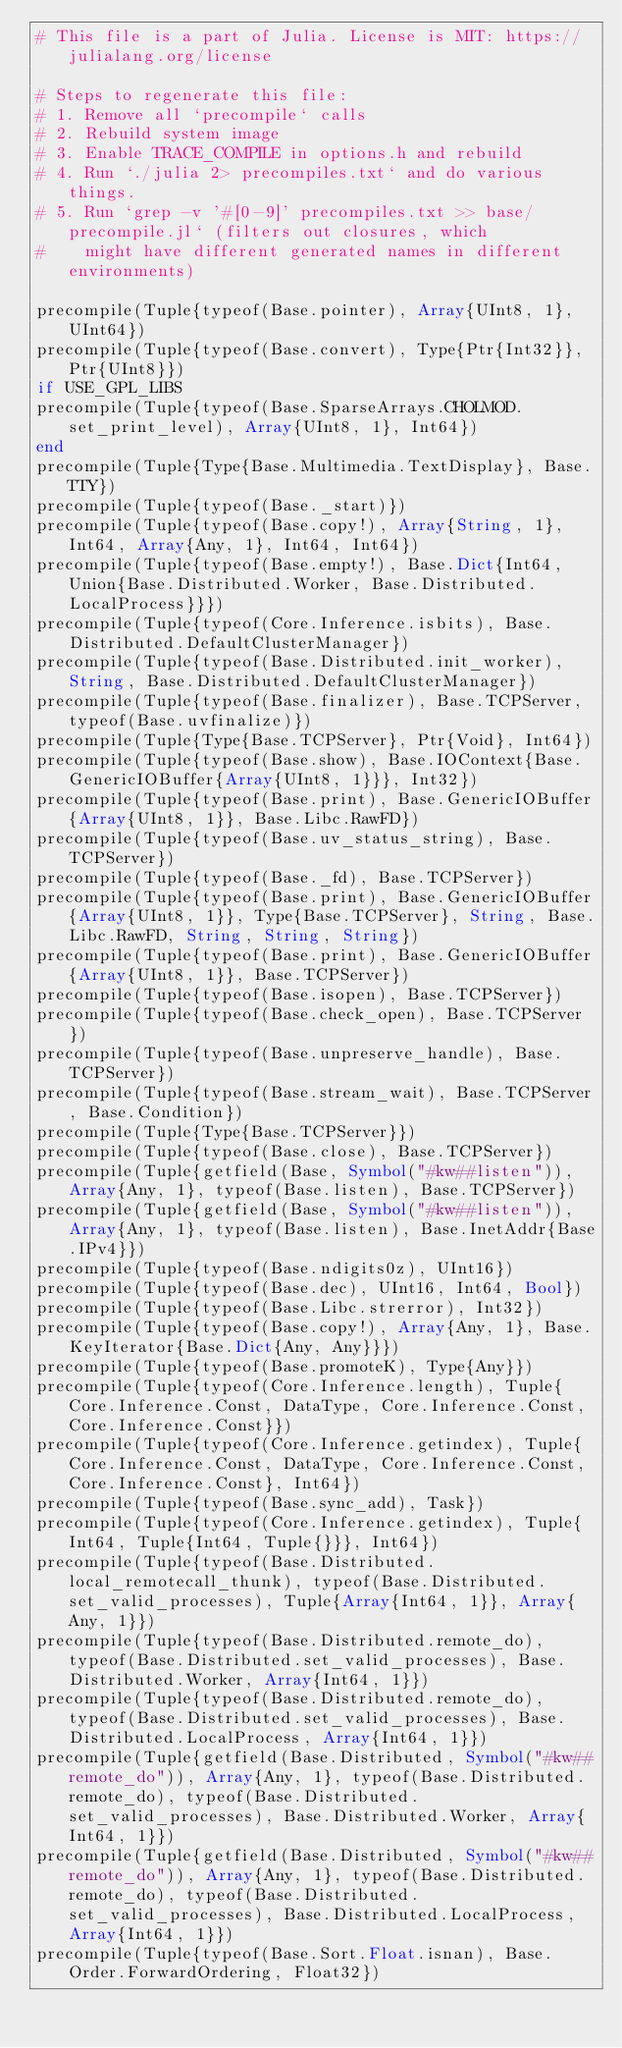<code> <loc_0><loc_0><loc_500><loc_500><_Julia_># This file is a part of Julia. License is MIT: https://julialang.org/license

# Steps to regenerate this file:
# 1. Remove all `precompile` calls
# 2. Rebuild system image
# 3. Enable TRACE_COMPILE in options.h and rebuild
# 4. Run `./julia 2> precompiles.txt` and do various things.
# 5. Run `grep -v '#[0-9]' precompiles.txt >> base/precompile.jl` (filters out closures, which
#    might have different generated names in different environments)

precompile(Tuple{typeof(Base.pointer), Array{UInt8, 1}, UInt64})
precompile(Tuple{typeof(Base.convert), Type{Ptr{Int32}}, Ptr{UInt8}})
if USE_GPL_LIBS
precompile(Tuple{typeof(Base.SparseArrays.CHOLMOD.set_print_level), Array{UInt8, 1}, Int64})
end
precompile(Tuple{Type{Base.Multimedia.TextDisplay}, Base.TTY})
precompile(Tuple{typeof(Base._start)})
precompile(Tuple{typeof(Base.copy!), Array{String, 1}, Int64, Array{Any, 1}, Int64, Int64})
precompile(Tuple{typeof(Base.empty!), Base.Dict{Int64, Union{Base.Distributed.Worker, Base.Distributed.LocalProcess}}})
precompile(Tuple{typeof(Core.Inference.isbits), Base.Distributed.DefaultClusterManager})
precompile(Tuple{typeof(Base.Distributed.init_worker), String, Base.Distributed.DefaultClusterManager})
precompile(Tuple{typeof(Base.finalizer), Base.TCPServer, typeof(Base.uvfinalize)})
precompile(Tuple{Type{Base.TCPServer}, Ptr{Void}, Int64})
precompile(Tuple{typeof(Base.show), Base.IOContext{Base.GenericIOBuffer{Array{UInt8, 1}}}, Int32})
precompile(Tuple{typeof(Base.print), Base.GenericIOBuffer{Array{UInt8, 1}}, Base.Libc.RawFD})
precompile(Tuple{typeof(Base.uv_status_string), Base.TCPServer})
precompile(Tuple{typeof(Base._fd), Base.TCPServer})
precompile(Tuple{typeof(Base.print), Base.GenericIOBuffer{Array{UInt8, 1}}, Type{Base.TCPServer}, String, Base.Libc.RawFD, String, String, String})
precompile(Tuple{typeof(Base.print), Base.GenericIOBuffer{Array{UInt8, 1}}, Base.TCPServer})
precompile(Tuple{typeof(Base.isopen), Base.TCPServer})
precompile(Tuple{typeof(Base.check_open), Base.TCPServer})
precompile(Tuple{typeof(Base.unpreserve_handle), Base.TCPServer})
precompile(Tuple{typeof(Base.stream_wait), Base.TCPServer, Base.Condition})
precompile(Tuple{Type{Base.TCPServer}})
precompile(Tuple{typeof(Base.close), Base.TCPServer})
precompile(Tuple{getfield(Base, Symbol("#kw##listen")), Array{Any, 1}, typeof(Base.listen), Base.TCPServer})
precompile(Tuple{getfield(Base, Symbol("#kw##listen")), Array{Any, 1}, typeof(Base.listen), Base.InetAddr{Base.IPv4}})
precompile(Tuple{typeof(Base.ndigits0z), UInt16})
precompile(Tuple{typeof(Base.dec), UInt16, Int64, Bool})
precompile(Tuple{typeof(Base.Libc.strerror), Int32})
precompile(Tuple{typeof(Base.copy!), Array{Any, 1}, Base.KeyIterator{Base.Dict{Any, Any}}})
precompile(Tuple{typeof(Base.promoteK), Type{Any}})
precompile(Tuple{typeof(Core.Inference.length), Tuple{Core.Inference.Const, DataType, Core.Inference.Const, Core.Inference.Const}})
precompile(Tuple{typeof(Core.Inference.getindex), Tuple{Core.Inference.Const, DataType, Core.Inference.Const, Core.Inference.Const}, Int64})
precompile(Tuple{typeof(Base.sync_add), Task})
precompile(Tuple{typeof(Core.Inference.getindex), Tuple{Int64, Tuple{Int64, Tuple{}}}, Int64})
precompile(Tuple{typeof(Base.Distributed.local_remotecall_thunk), typeof(Base.Distributed.set_valid_processes), Tuple{Array{Int64, 1}}, Array{Any, 1}})
precompile(Tuple{typeof(Base.Distributed.remote_do), typeof(Base.Distributed.set_valid_processes), Base.Distributed.Worker, Array{Int64, 1}})
precompile(Tuple{typeof(Base.Distributed.remote_do), typeof(Base.Distributed.set_valid_processes), Base.Distributed.LocalProcess, Array{Int64, 1}})
precompile(Tuple{getfield(Base.Distributed, Symbol("#kw##remote_do")), Array{Any, 1}, typeof(Base.Distributed.remote_do), typeof(Base.Distributed.set_valid_processes), Base.Distributed.Worker, Array{Int64, 1}})
precompile(Tuple{getfield(Base.Distributed, Symbol("#kw##remote_do")), Array{Any, 1}, typeof(Base.Distributed.remote_do), typeof(Base.Distributed.set_valid_processes), Base.Distributed.LocalProcess, Array{Int64, 1}})
precompile(Tuple{typeof(Base.Sort.Float.isnan), Base.Order.ForwardOrdering, Float32})</code> 